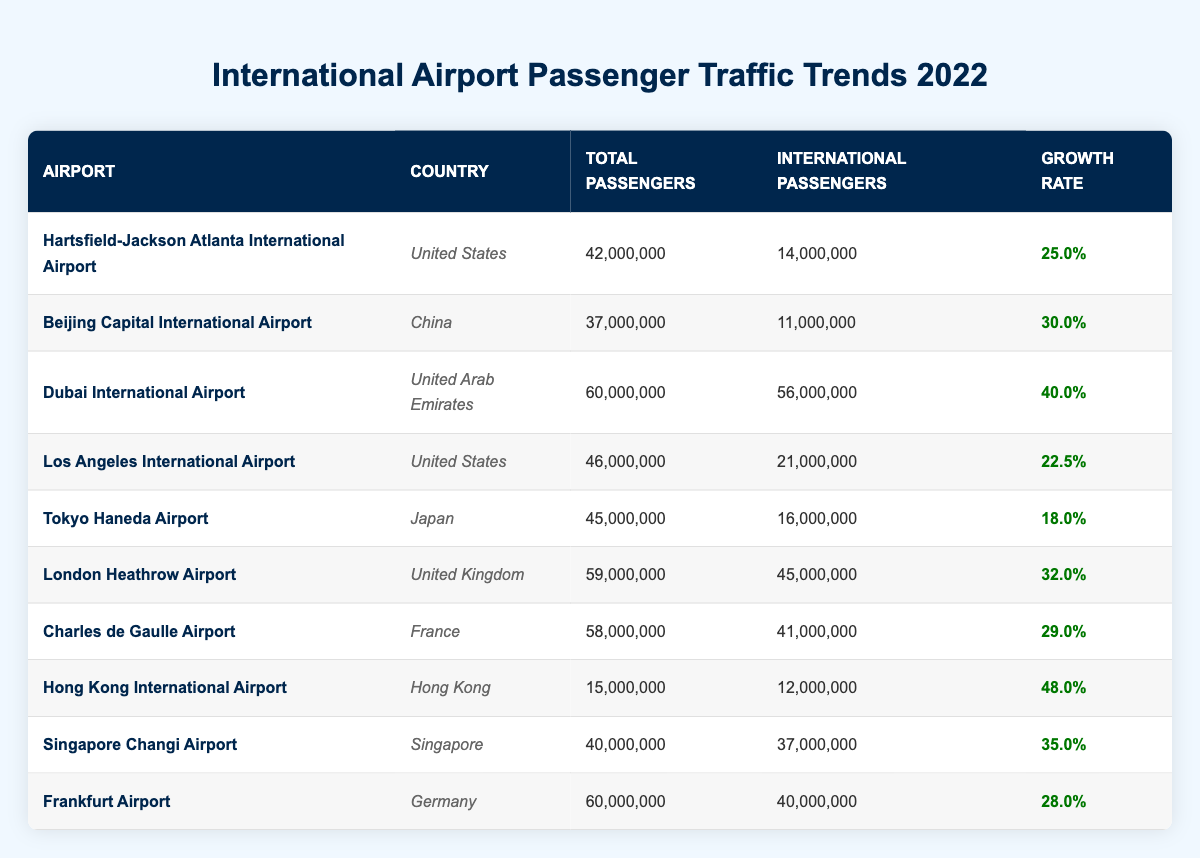What is the total number of international passengers at Dubai International Airport in 2022? The table shows "Dubai International Airport" in the row for that specific airport, and under the "International Passengers" column, it lists "56,000,000" as the total number of international passengers for the year 2022.
Answer: 56,000,000 Which airport had the highest growth rate in 2022? The table lists growth rates for each airport, with "Hong Kong International Airport" having the highest growth rate of "48.0%." This is verified by comparing all growth rate values in the corresponding column.
Answer: Hong Kong International Airport What is the total number of passengers for all the airports from the United States in 2022? The airports from the United States in the table are "Hartsfield-Jackson Atlanta International Airport" with 42,000,000 total passengers and "Los Angeles International Airport" with 46,000,000 total passengers. Adding these values together gives 42,000,000 + 46,000,000 = 88,000,000.
Answer: 88,000,000 Did Singapore Changi Airport have more international passengers than Tokyo Haneda Airport in 2022? The "International Passengers" for "Singapore Changi Airport" is 37,000,000 while for "Tokyo Haneda Airport," it is 16,000,000. As 37,000,000 is greater than 16,000,000, the answer is yes.
Answer: Yes What was the average growth rate of the airports listed in the table? The growth rates for the listed airports are 25.0, 30.0, 40.0, 22.5, 18.0, 32.0, 29.0, 48.0, 35.0, and 28.0. Adding these rates gives a total of  25.0 + 30.0 + 40.0 + 22.5 + 18.0 + 32.0 + 29.0 + 48.0 + 35.0 + 28.0 =  308.5. With 10 values, the average is  308.5 / 10 = 30.85.
Answer: 30.85 How many total passengers did Frankfurt Airport handle in 2022 compared to Beijing Capital International Airport? "Frankfurt Airport" had 60,000,000 total passengers, while "Beijing Capital International Airport" had 37,000,000. Comparing these two values, 60,000,000 is more than 37,000,000. Therefore, Frankfurt handled more passengers than Beijing in 2022.
Answer: Frankfurt Airport handled more passengers 